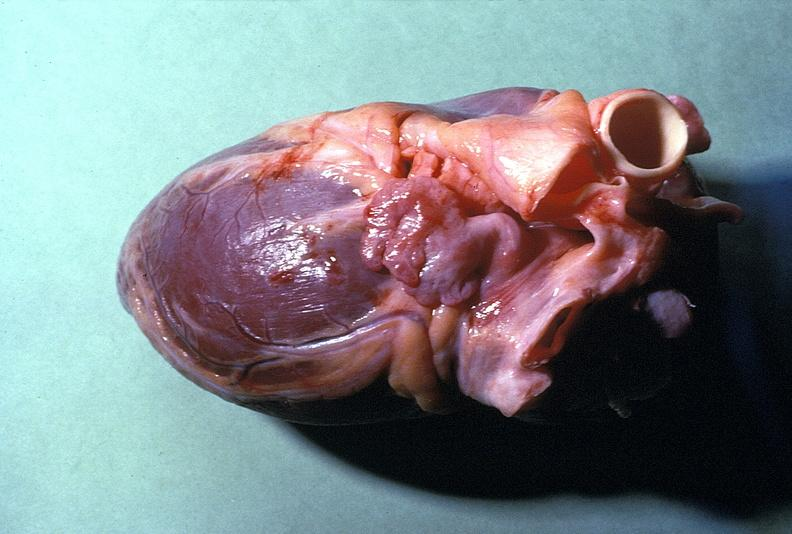where is this?
Answer the question using a single word or phrase. Heart 